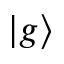<formula> <loc_0><loc_0><loc_500><loc_500>| g \rangle</formula> 